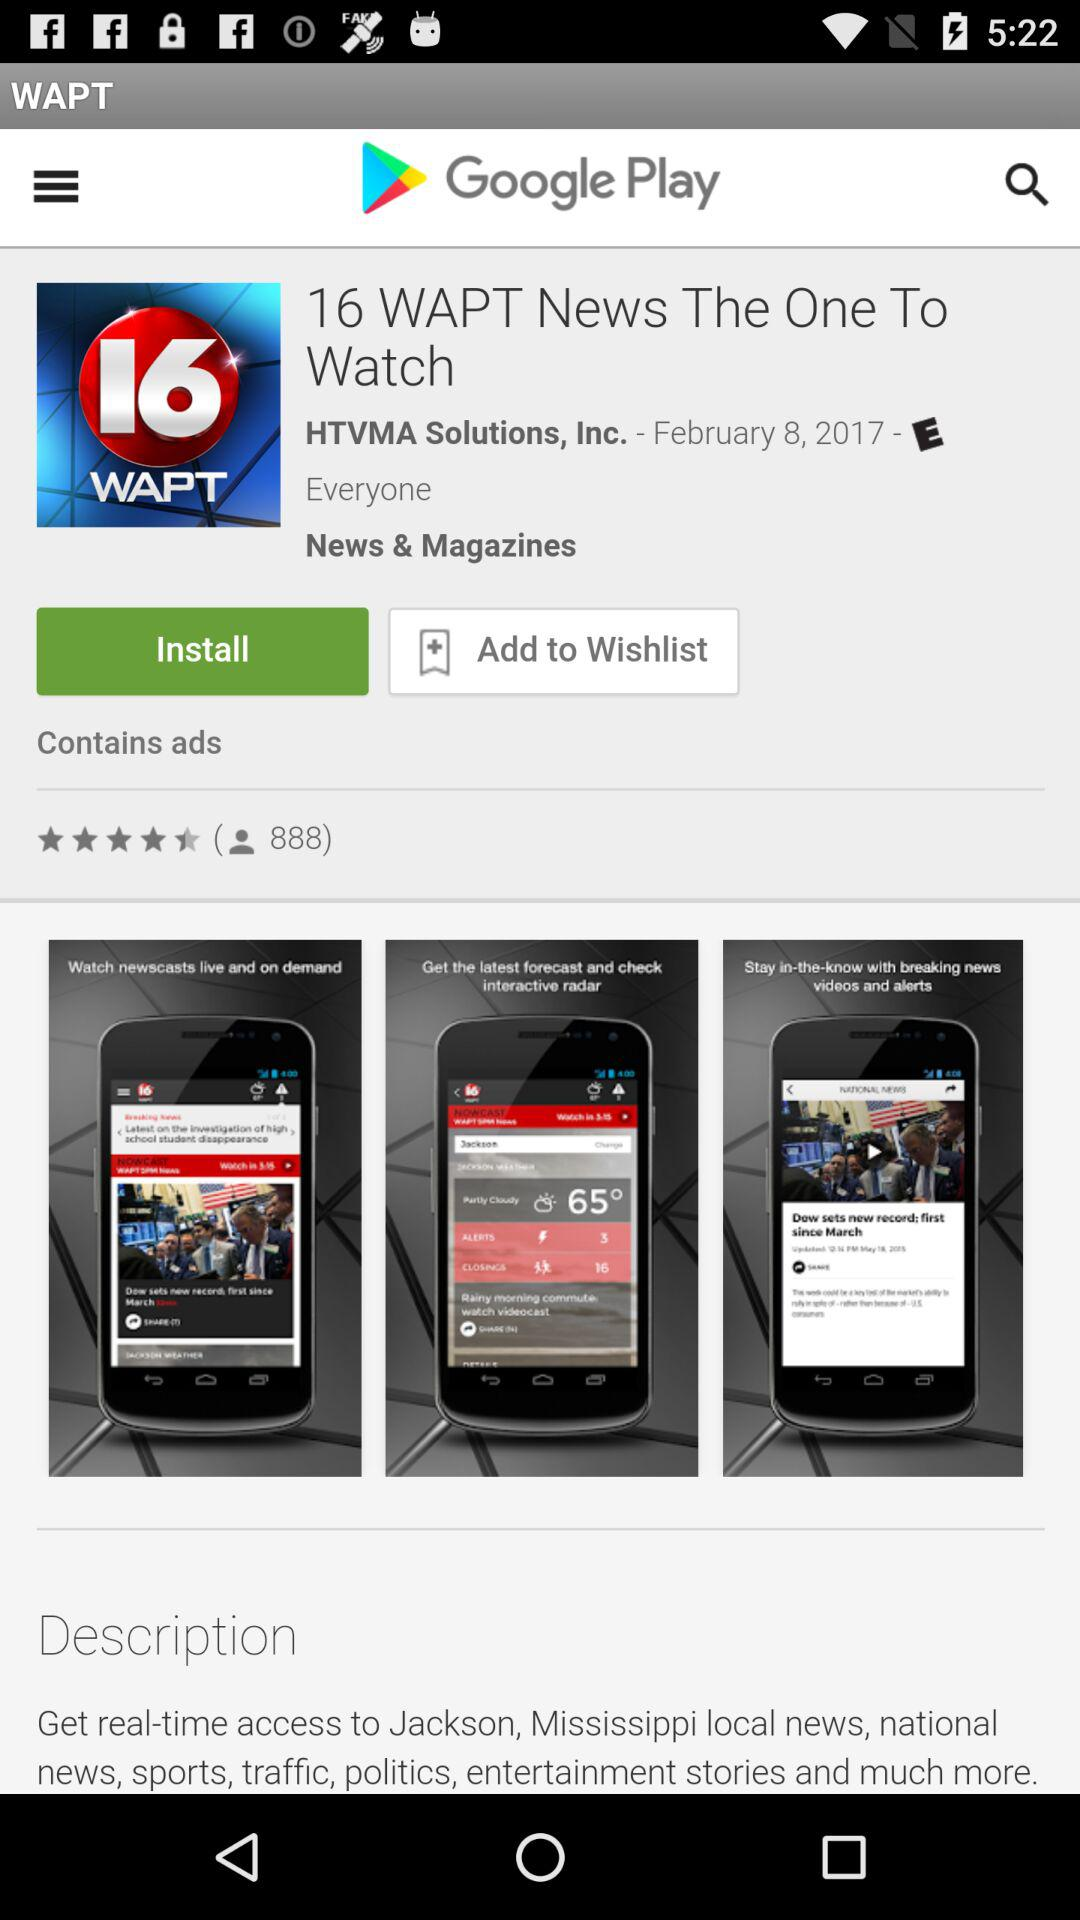How many categories does this app fall into?
Answer the question using a single word or phrase. 2 